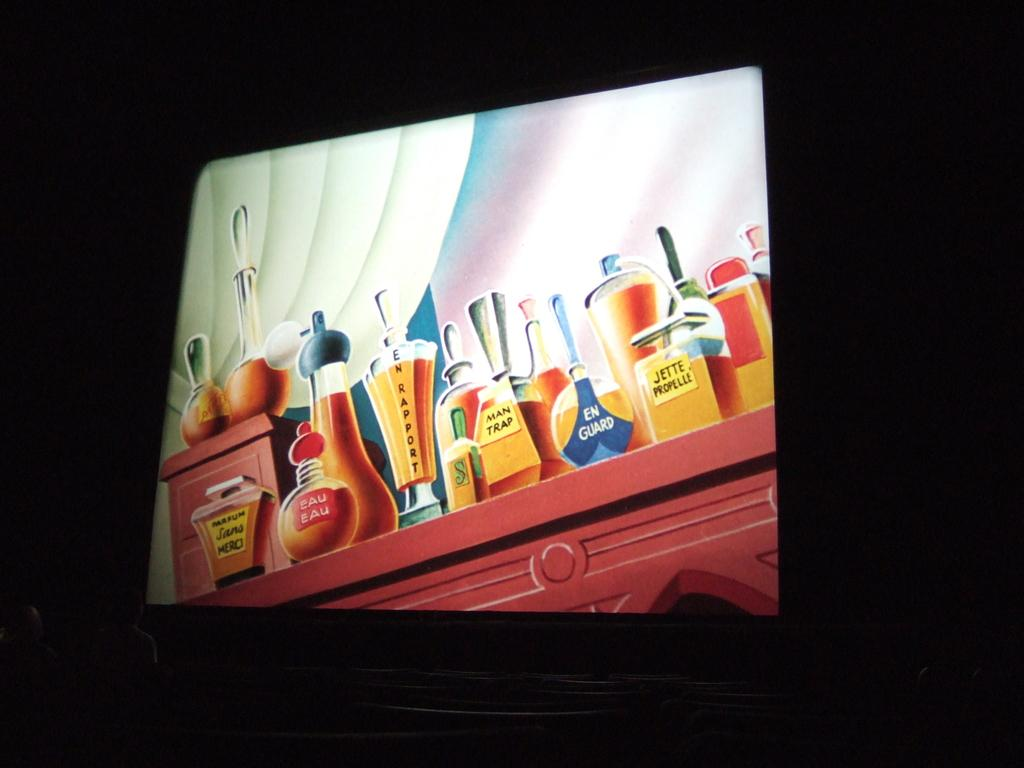<image>
Relay a brief, clear account of the picture shown. Display showing many cartoon perfumes and bottles with one that says MAN TRAP. 